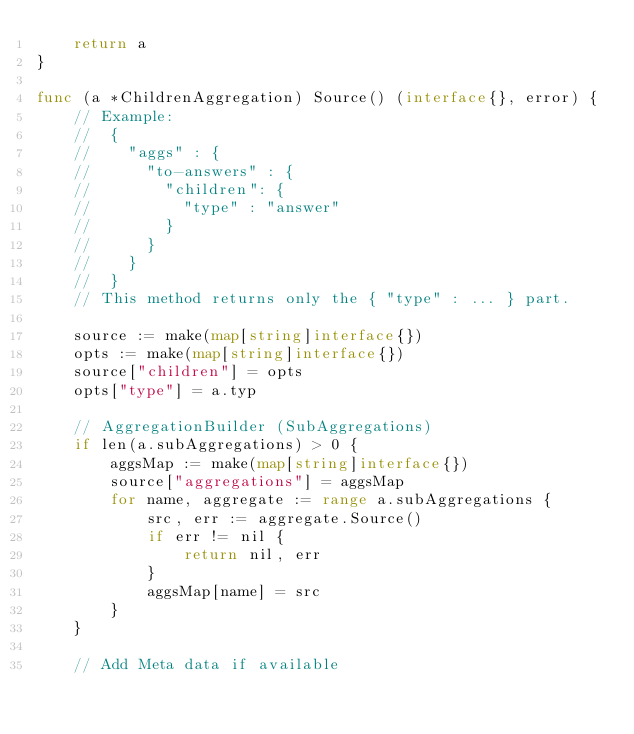Convert code to text. <code><loc_0><loc_0><loc_500><loc_500><_Go_>	return a
}

func (a *ChildrenAggregation) Source() (interface{}, error) {
	// Example:
	//	{
	//    "aggs" : {
	//      "to-answers" : {
	//        "children": {
	//          "type" : "answer"
	//        }
	//      }
	//    }
	//	}
	// This method returns only the { "type" : ... } part.

	source := make(map[string]interface{})
	opts := make(map[string]interface{})
	source["children"] = opts
	opts["type"] = a.typ

	// AggregationBuilder (SubAggregations)
	if len(a.subAggregations) > 0 {
		aggsMap := make(map[string]interface{})
		source["aggregations"] = aggsMap
		for name, aggregate := range a.subAggregations {
			src, err := aggregate.Source()
			if err != nil {
				return nil, err
			}
			aggsMap[name] = src
		}
	}

	// Add Meta data if available</code> 